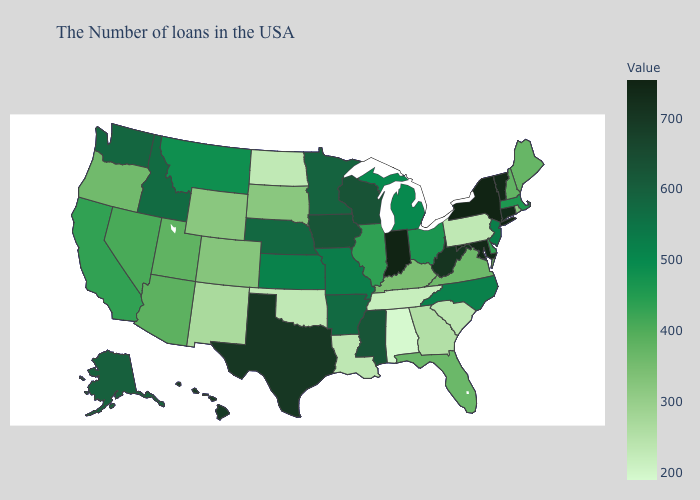Among the states that border Florida , which have the lowest value?
Answer briefly. Alabama. Among the states that border Mississippi , does Alabama have the lowest value?
Write a very short answer. Yes. Does West Virginia have the highest value in the USA?
Short answer required. No. 